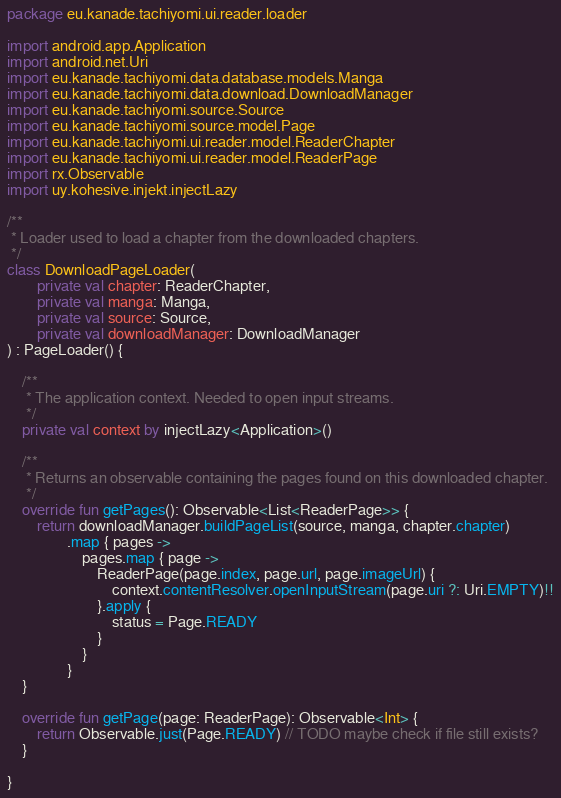Convert code to text. <code><loc_0><loc_0><loc_500><loc_500><_Kotlin_>package eu.kanade.tachiyomi.ui.reader.loader

import android.app.Application
import android.net.Uri
import eu.kanade.tachiyomi.data.database.models.Manga
import eu.kanade.tachiyomi.data.download.DownloadManager
import eu.kanade.tachiyomi.source.Source
import eu.kanade.tachiyomi.source.model.Page
import eu.kanade.tachiyomi.ui.reader.model.ReaderChapter
import eu.kanade.tachiyomi.ui.reader.model.ReaderPage
import rx.Observable
import uy.kohesive.injekt.injectLazy

/**
 * Loader used to load a chapter from the downloaded chapters.
 */
class DownloadPageLoader(
        private val chapter: ReaderChapter,
        private val manga: Manga,
        private val source: Source,
        private val downloadManager: DownloadManager
) : PageLoader() {

    /**
     * The application context. Needed to open input streams.
     */
    private val context by injectLazy<Application>()

    /**
     * Returns an observable containing the pages found on this downloaded chapter.
     */
    override fun getPages(): Observable<List<ReaderPage>> {
        return downloadManager.buildPageList(source, manga, chapter.chapter)
                .map { pages ->
                    pages.map { page ->
                        ReaderPage(page.index, page.url, page.imageUrl) {
                            context.contentResolver.openInputStream(page.uri ?: Uri.EMPTY)!!
                        }.apply {
                            status = Page.READY
                        }
                    }
                }
    }

    override fun getPage(page: ReaderPage): Observable<Int> {
        return Observable.just(Page.READY) // TODO maybe check if file still exists?
    }

}
</code> 